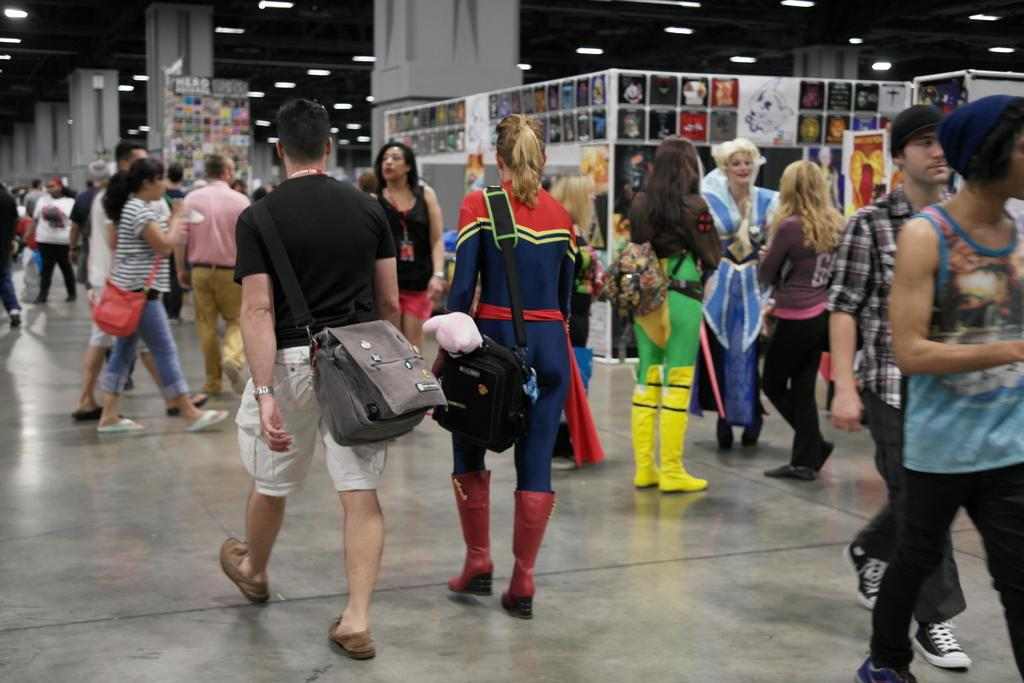Where was the image taken? The image was taken in a hall. What can be seen in the hall? There are people standing in the hall. What surface are the people standing on? The people are standing on the floor. What architectural feature is visible in the background? There is a pillar in the background. What can be seen above the people in the image? There is a roof with lights in the background. What type of cloth is draped over the deer in the image? There is no deer or cloth present in the image; it features people standing in a hall with a pillar and a roof with lights in the background. 